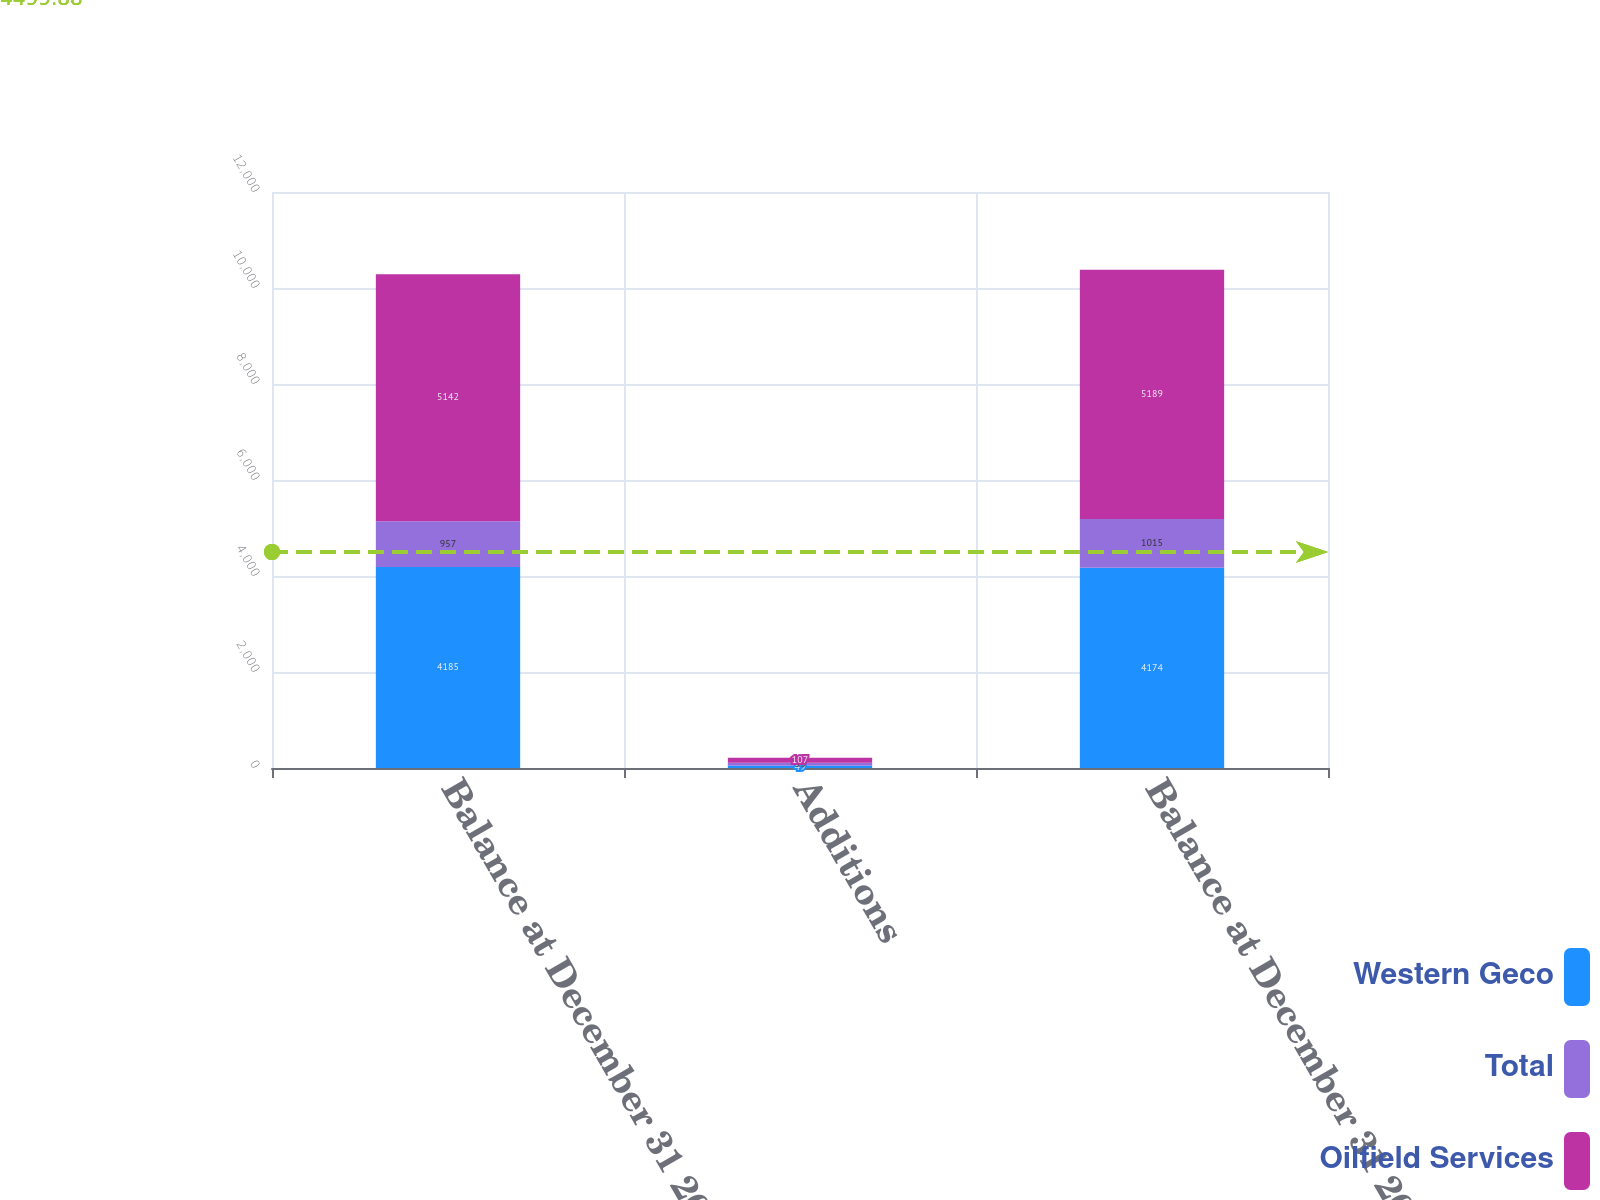Convert chart to OTSL. <chart><loc_0><loc_0><loc_500><loc_500><stacked_bar_chart><ecel><fcel>Balance at December 31 2007<fcel>Additions<fcel>Balance at December 31 2008<nl><fcel>Western Geco<fcel>4185<fcel>49<fcel>4174<nl><fcel>Total<fcel>957<fcel>58<fcel>1015<nl><fcel>Oilfield Services<fcel>5142<fcel>107<fcel>5189<nl></chart> 